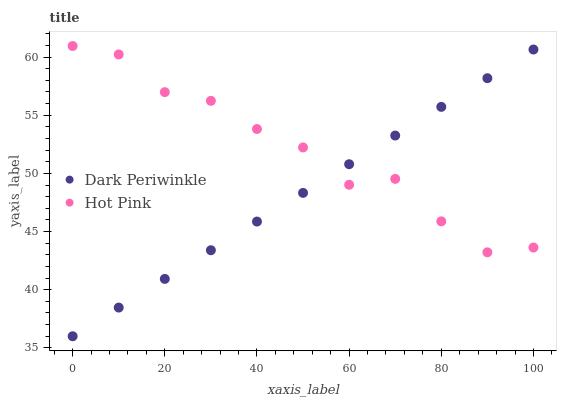Does Dark Periwinkle have the minimum area under the curve?
Answer yes or no. Yes. Does Hot Pink have the maximum area under the curve?
Answer yes or no. Yes. Does Dark Periwinkle have the maximum area under the curve?
Answer yes or no. No. Is Dark Periwinkle the smoothest?
Answer yes or no. Yes. Is Hot Pink the roughest?
Answer yes or no. Yes. Is Dark Periwinkle the roughest?
Answer yes or no. No. Does Dark Periwinkle have the lowest value?
Answer yes or no. Yes. Does Hot Pink have the highest value?
Answer yes or no. Yes. Does Dark Periwinkle have the highest value?
Answer yes or no. No. Does Dark Periwinkle intersect Hot Pink?
Answer yes or no. Yes. Is Dark Periwinkle less than Hot Pink?
Answer yes or no. No. Is Dark Periwinkle greater than Hot Pink?
Answer yes or no. No. 